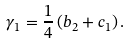Convert formula to latex. <formula><loc_0><loc_0><loc_500><loc_500>\gamma _ { 1 } = \frac { 1 } { 4 } \left ( b _ { 2 } + c _ { 1 } \right ) .</formula> 